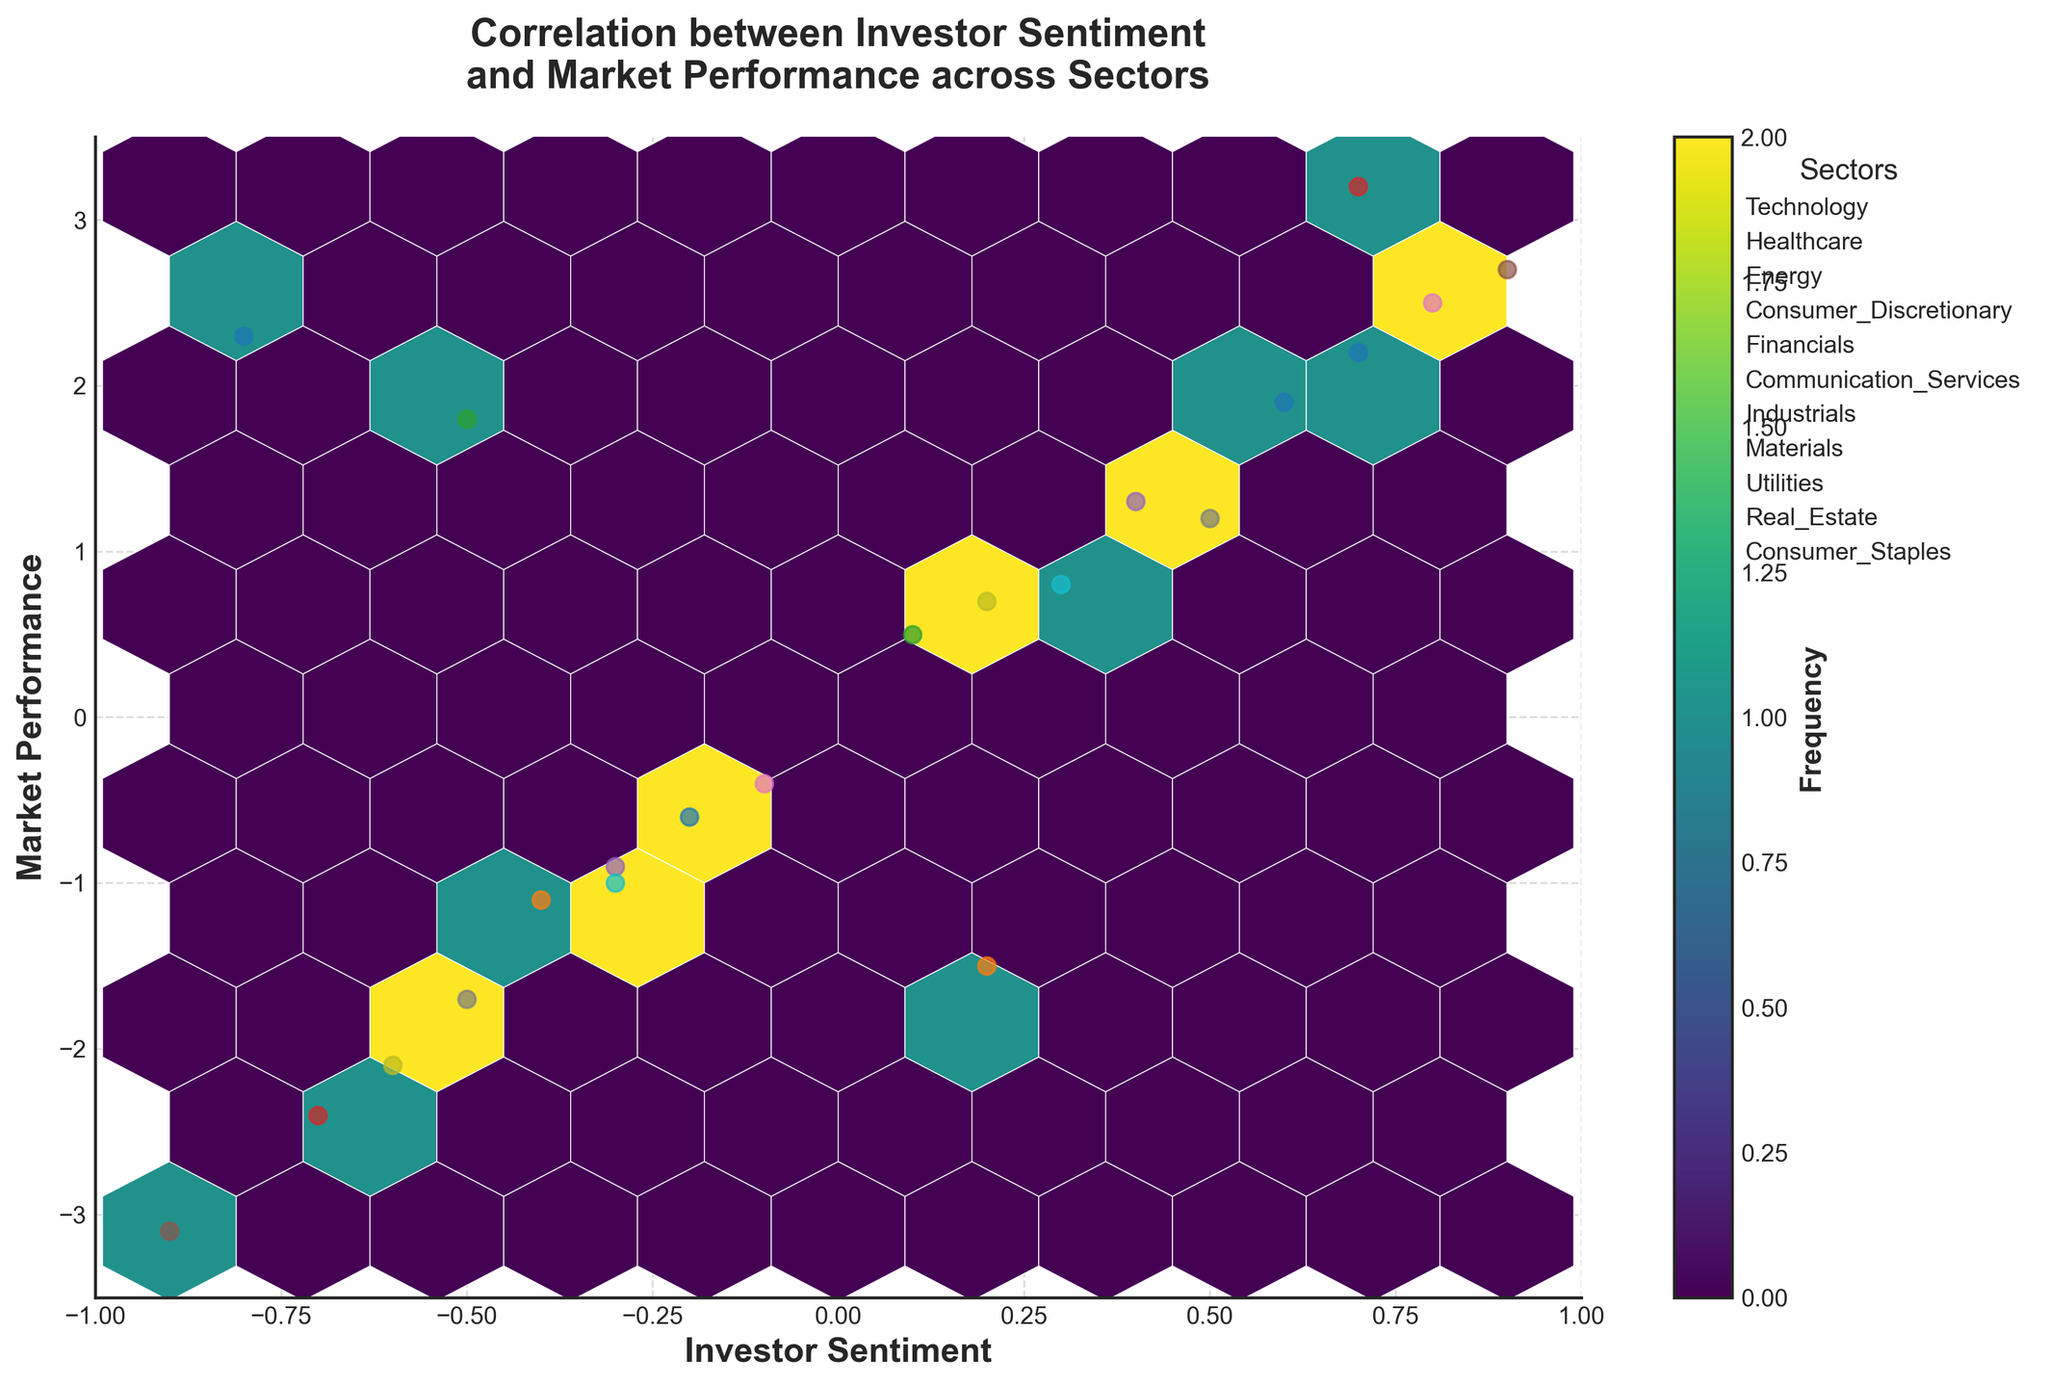What is the title of the hexbin plot? The title of the hexbin plot is written at the top and provides an overview of what the plot represents. It states the main relationship being analyzed.
Answer: Correlation between Investor Sentiment and Market Performance across Sectors What are the labels for the x-axis and the y-axis? The labels for the axes are found next to each respective axis. They provide information on what the horizontal (x-axis) and vertical (y-axis) represent in the plot.
Answer: Investor Sentiment (x-axis), Market Performance (y-axis) What is the color bar label in the plot? The color bar indicates the frequency of data points in different hexagon bins and has a label describing what it measures.
Answer: Frequency How many sectors are represented in the scatter overlay of the hexbin plot? By looking at the legend on the plot, which provides information about the various sectors represented by different colors and markers, we can count the number of unique sectors.
Answer: 10 Which sector appears to have the highest individual Investor Sentiment on the positive side? By examining the scatter points in the hexbin plot, we look for the highest positive value on the x-axis related to a sector in the legend.
Answer: Communication Services What range of Investor Sentiment values appears to show most activity (higher frequency) in the plot? The hexbin plot uses color intensity to represent frequency. By examining where the densest aggregation of colors (typically the darkest) appear along the x-axis, we can determine the range of Investor Sentiment values with the most activity.
Answer: Approximately between -0.5 and 0.5 Which sector shows the most negative Market Performance? By examining the scatter points on the hexbin plot, we look for the lowest value on the y-axis correlated with a sector indicated in the legend.
Answer: Communication Services Are there sectors that exhibit a positive trend in Market Performance with increasing Investor Sentiment? A positive trend means that as Investor Sentiment increases on the x-axis, Market Performance also increases on the y-axis. By examining the placement of sector points, we can identify these positive trends.
Answer: Yes, notably Consumer Discretionary and Technology Compare the Market Performance of the Technology sector to the Financials sector? By looking at the clutter of points labeled Technology and Financials in the legend, we compare the general placements on the y-axis to determine their Market Performances.
Answer: Technology sector generally shows higher Market Performance than Financials sector What is the general relationship between Investor Sentiment and Market Performance overall, judging from the hexbin plot? Considering the overall color density patterns and the spread of the plotted sectors, we can determine if there is an apparent trend where Market Performance tends to increase or decrease with Investor Sentiment.
Answer: Generally, there is a mixed relationship, but some sectors show a positive correlation 